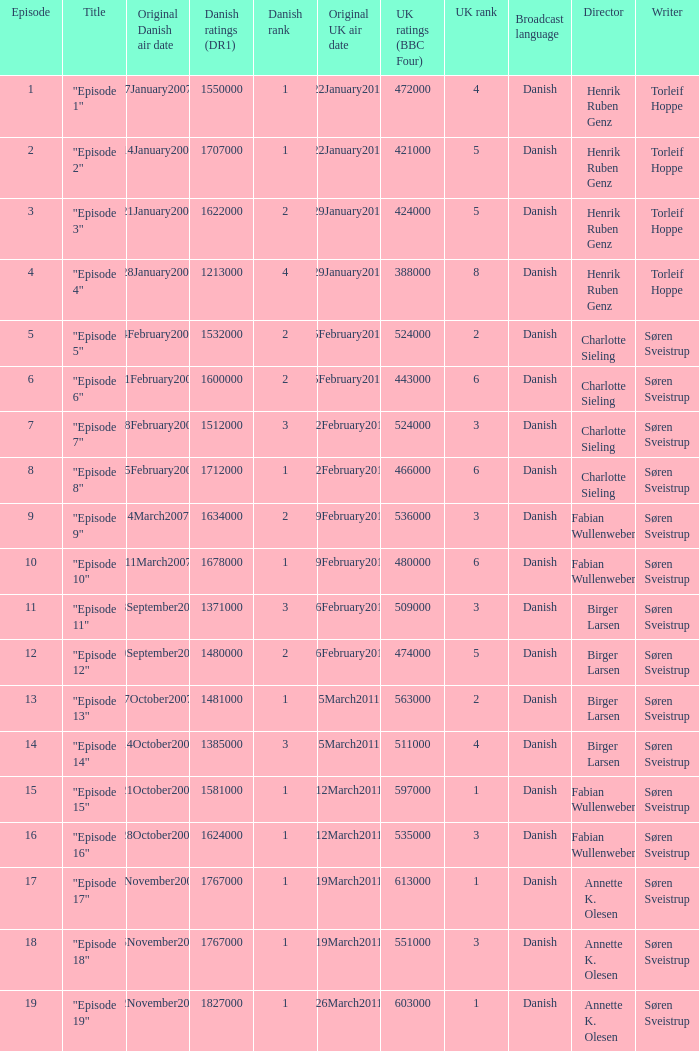What were the UK ratings (BBC Four) for "Episode 17"?  613000.0. 